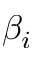Convert formula to latex. <formula><loc_0><loc_0><loc_500><loc_500>\beta _ { i }</formula> 